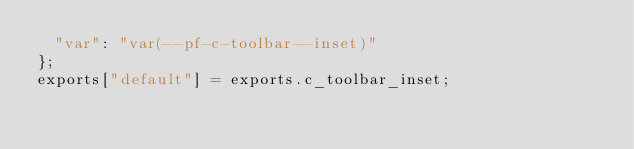<code> <loc_0><loc_0><loc_500><loc_500><_JavaScript_>  "var": "var(--pf-c-toolbar--inset)"
};
exports["default"] = exports.c_toolbar_inset;</code> 